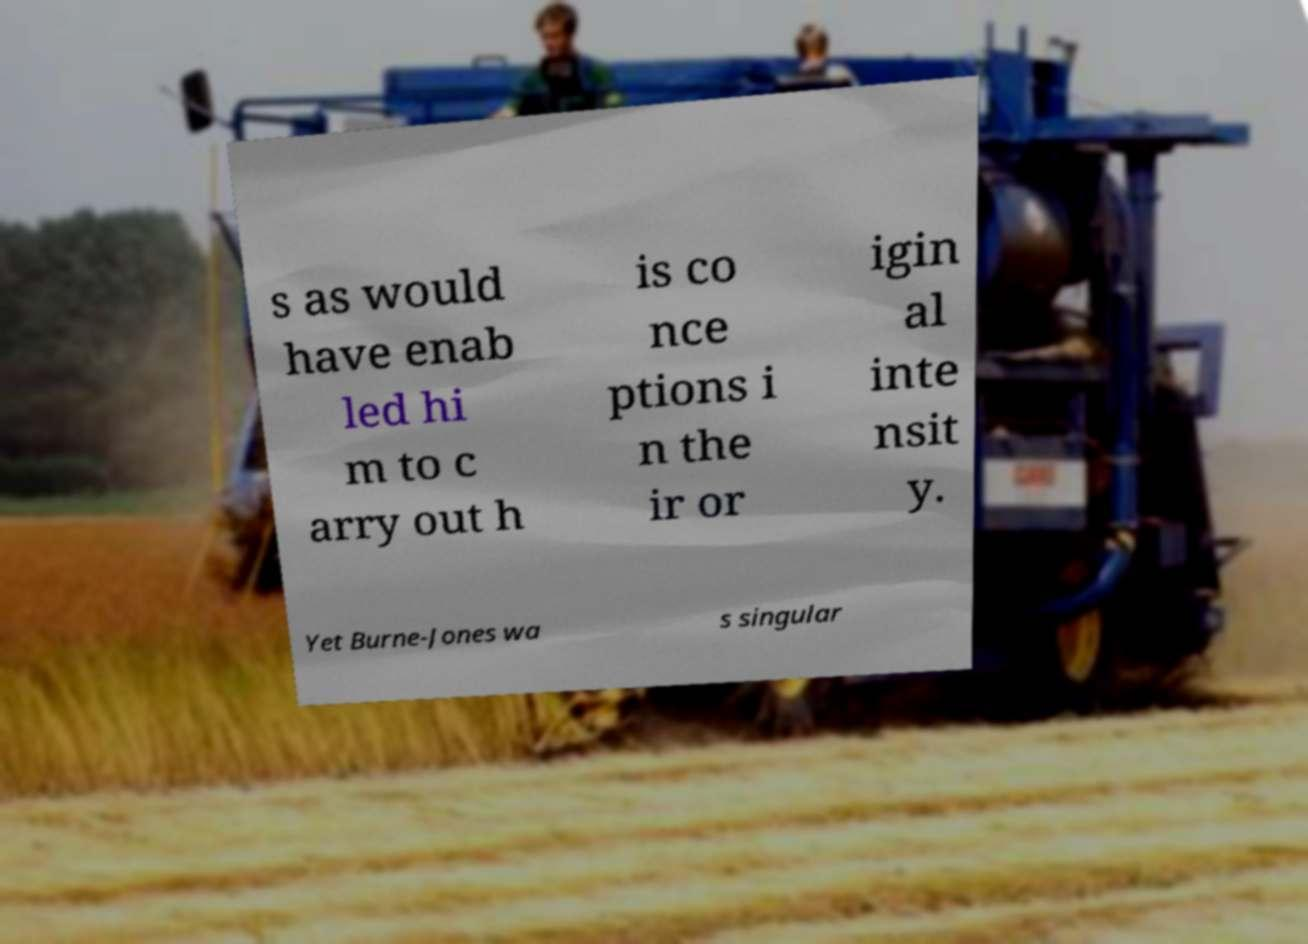Please identify and transcribe the text found in this image. s as would have enab led hi m to c arry out h is co nce ptions i n the ir or igin al inte nsit y. Yet Burne-Jones wa s singular 